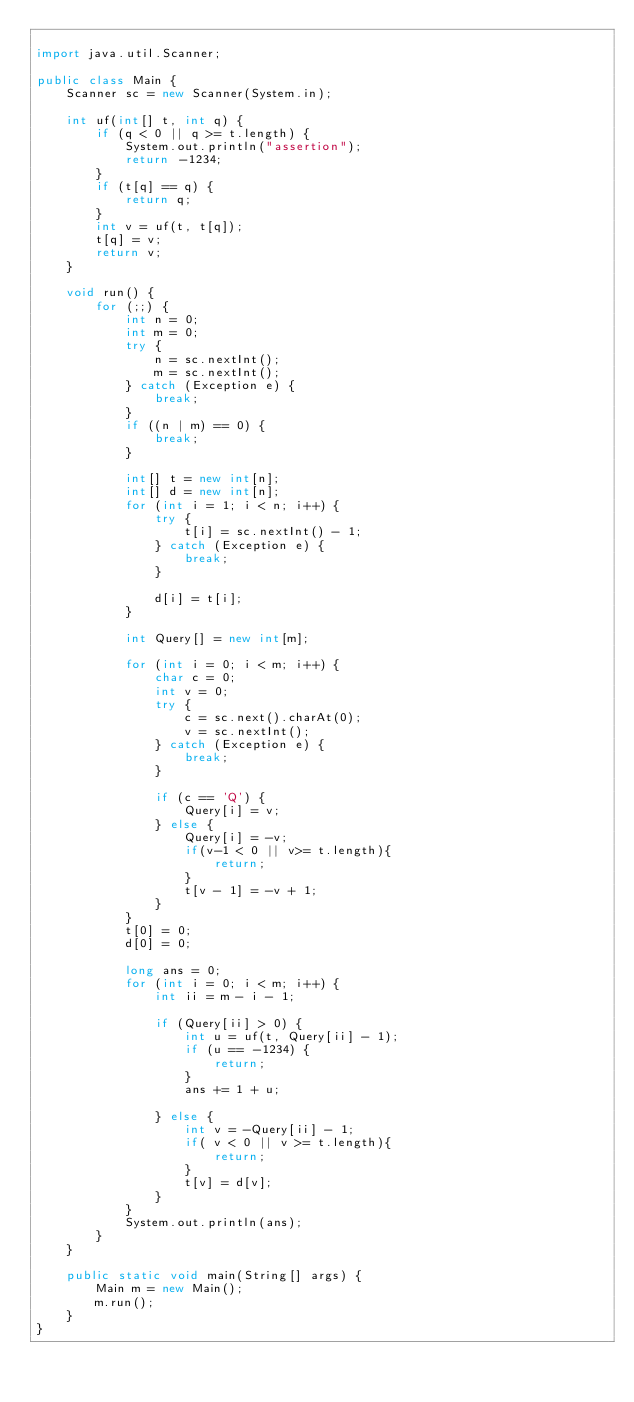Convert code to text. <code><loc_0><loc_0><loc_500><loc_500><_Java_>
import java.util.Scanner;

public class Main {
	Scanner sc = new Scanner(System.in);

	int uf(int[] t, int q) {
		if (q < 0 || q >= t.length) {
			System.out.println("assertion");
			return -1234;
		}
		if (t[q] == q) {
			return q;
		}
		int v = uf(t, t[q]);
		t[q] = v;
		return v;
	}

	void run() {
		for (;;) {
			int n = 0;
			int m = 0;
			try {
				n = sc.nextInt();
				m = sc.nextInt();
			} catch (Exception e) {
				break;
			}
			if ((n | m) == 0) {
				break;
			}

			int[] t = new int[n];
			int[] d = new int[n];
			for (int i = 1; i < n; i++) {
				try {
					t[i] = sc.nextInt() - 1;
				} catch (Exception e) {
					break;
				}

				d[i] = t[i];
			}

			int Query[] = new int[m];

			for (int i = 0; i < m; i++) {
				char c = 0;
				int v = 0;
				try {
					c = sc.next().charAt(0);
					v = sc.nextInt();
				} catch (Exception e) {
					break;
				}

				if (c == 'Q') {
					Query[i] = v;
				} else {
					Query[i] = -v;
					if(v-1 < 0 || v>= t.length){
						return;
					}
					t[v - 1] = -v + 1;
				}
			}
			t[0] = 0;
			d[0] = 0;

			long ans = 0;
			for (int i = 0; i < m; i++) {
				int ii = m - i - 1;

				if (Query[ii] > 0) {
					int u = uf(t, Query[ii] - 1);
					if (u == -1234) {
						return;
					}
					ans += 1 + u;

				} else {
					int v = -Query[ii] - 1;
					if( v < 0 || v >= t.length){
						return;
					}
					t[v] = d[v];
				}
			}
			System.out.println(ans);
		}
	}

	public static void main(String[] args) {
		Main m = new Main();
		m.run();
	}
}</code> 